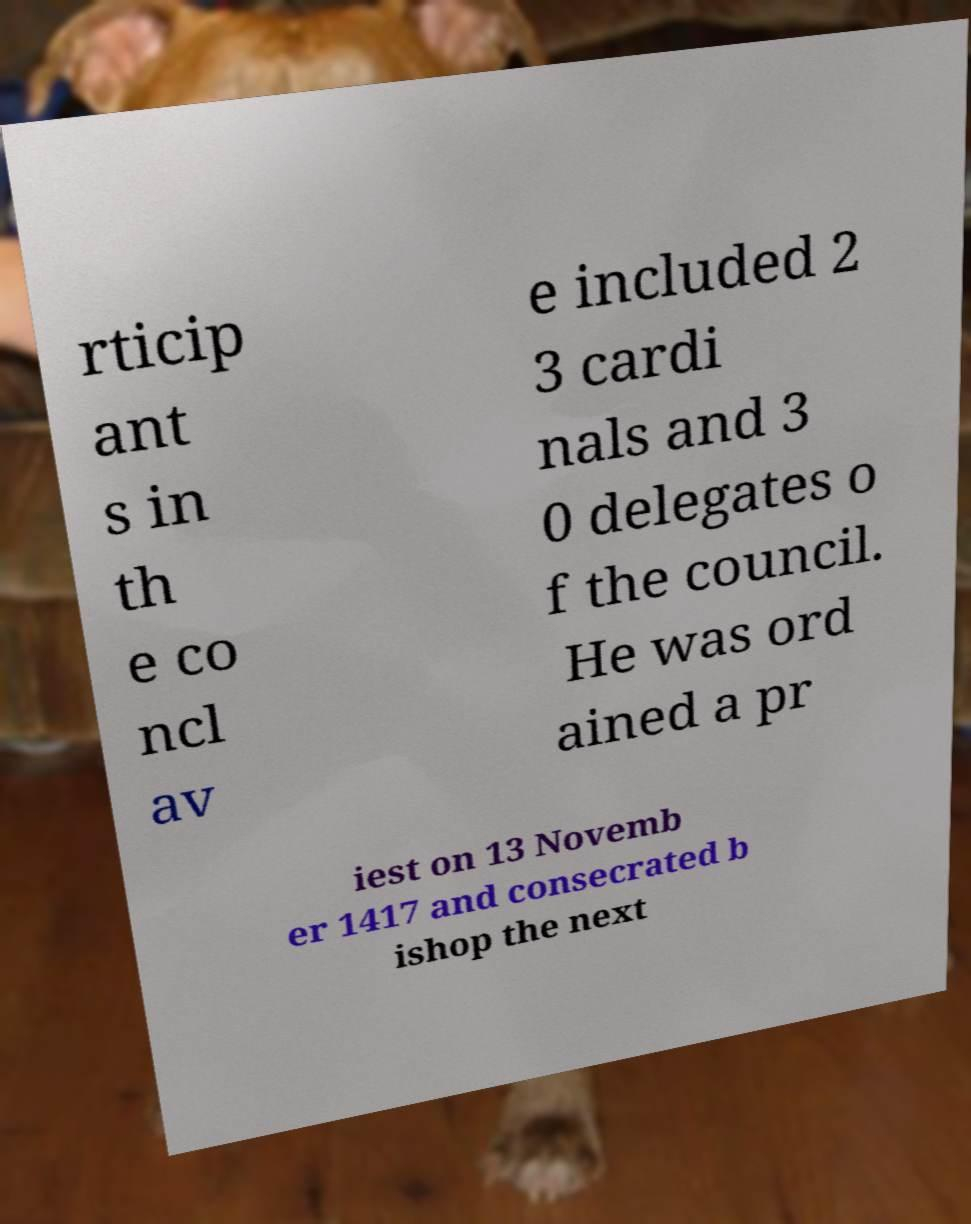There's text embedded in this image that I need extracted. Can you transcribe it verbatim? rticip ant s in th e co ncl av e included 2 3 cardi nals and 3 0 delegates o f the council. He was ord ained a pr iest on 13 Novemb er 1417 and consecrated b ishop the next 